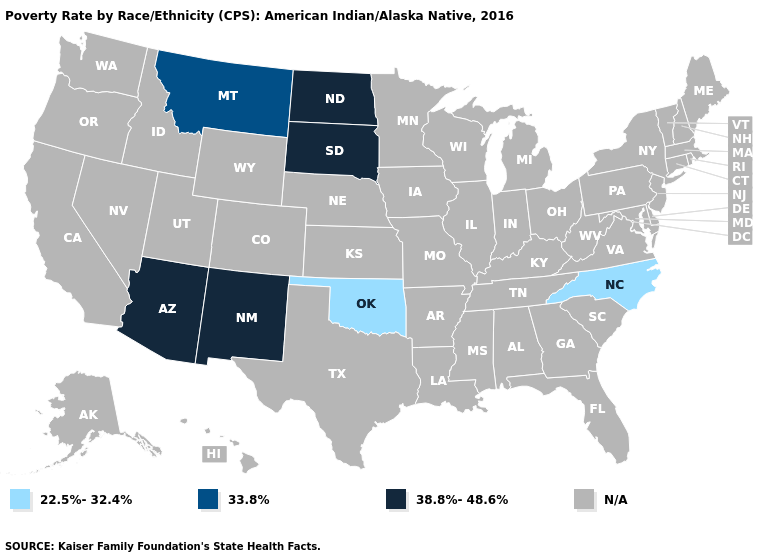Name the states that have a value in the range 33.8%?
Answer briefly. Montana. What is the value of Mississippi?
Keep it brief. N/A. Name the states that have a value in the range 33.8%?
Concise answer only. Montana. Which states have the lowest value in the West?
Quick response, please. Montana. What is the value of Minnesota?
Be succinct. N/A. What is the value of Utah?
Short answer required. N/A. What is the value of New York?
Give a very brief answer. N/A. Is the legend a continuous bar?
Answer briefly. No. What is the lowest value in the USA?
Concise answer only. 22.5%-32.4%. What is the value of Vermont?
Answer briefly. N/A. Is the legend a continuous bar?
Give a very brief answer. No. Name the states that have a value in the range 38.8%-48.6%?
Keep it brief. Arizona, New Mexico, North Dakota, South Dakota. 